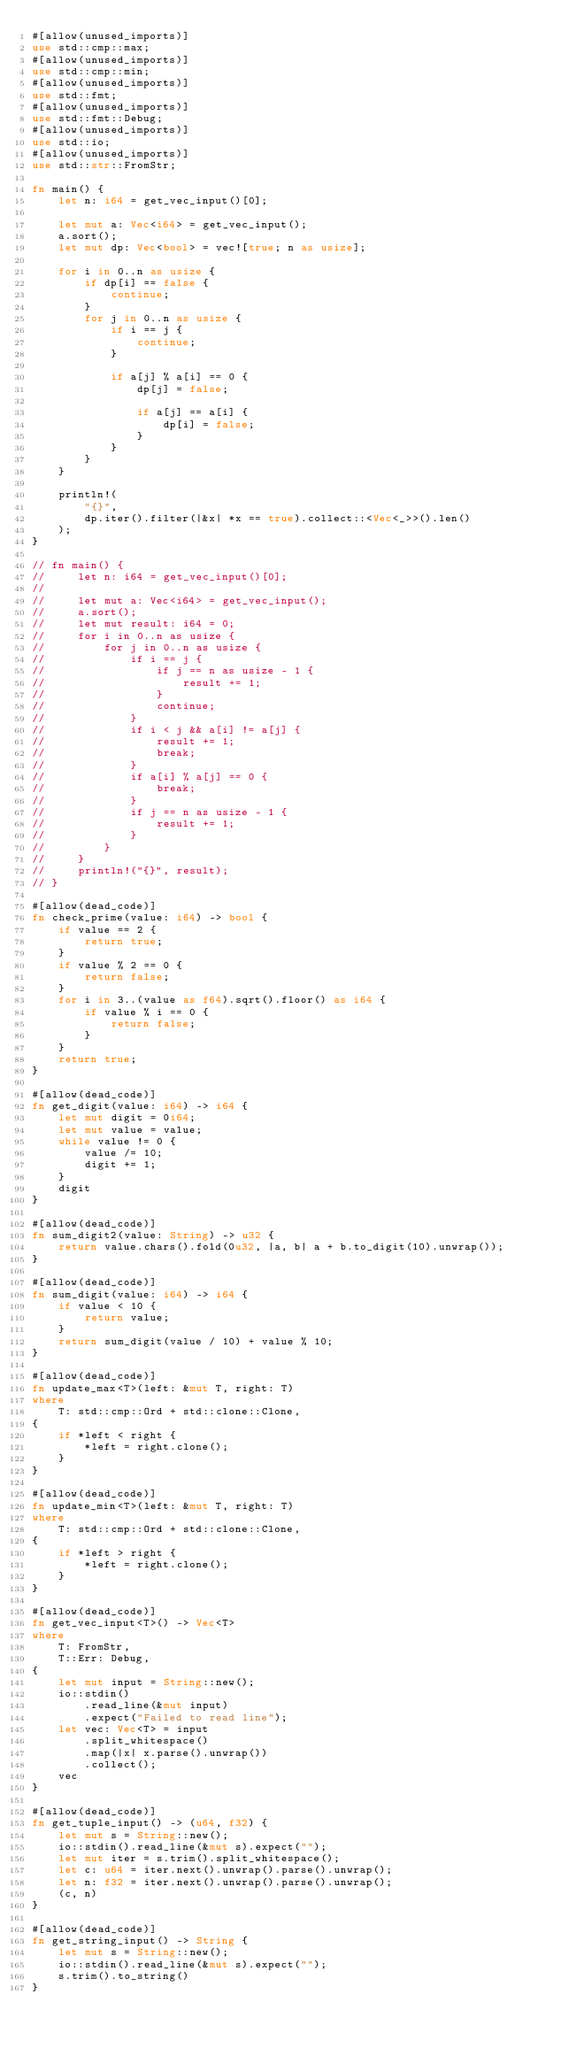Convert code to text. <code><loc_0><loc_0><loc_500><loc_500><_Rust_>#[allow(unused_imports)]
use std::cmp::max;
#[allow(unused_imports)]
use std::cmp::min;
#[allow(unused_imports)]
use std::fmt;
#[allow(unused_imports)]
use std::fmt::Debug;
#[allow(unused_imports)]
use std::io;
#[allow(unused_imports)]
use std::str::FromStr;

fn main() {
    let n: i64 = get_vec_input()[0];

    let mut a: Vec<i64> = get_vec_input();
    a.sort();
    let mut dp: Vec<bool> = vec![true; n as usize];

    for i in 0..n as usize {
        if dp[i] == false {
            continue;
        }
        for j in 0..n as usize {
            if i == j {
                continue;
            }

            if a[j] % a[i] == 0 {
                dp[j] = false;

                if a[j] == a[i] {
                    dp[i] = false;
                }
            }
        }
    }

    println!(
        "{}",
        dp.iter().filter(|&x| *x == true).collect::<Vec<_>>().len()
    );
}

// fn main() {
//     let n: i64 = get_vec_input()[0];
//
//     let mut a: Vec<i64> = get_vec_input();
//     a.sort();
//     let mut result: i64 = 0;
//     for i in 0..n as usize {
//         for j in 0..n as usize {
//             if i == j {
//                 if j == n as usize - 1 {
//                     result += 1;
//                 }
//                 continue;
//             }
//             if i < j && a[i] != a[j] {
//                 result += 1;
//                 break;
//             }
//             if a[i] % a[j] == 0 {
//                 break;
//             }
//             if j == n as usize - 1 {
//                 result += 1;
//             }
//         }
//     }
//     println!("{}", result);
// }

#[allow(dead_code)]
fn check_prime(value: i64) -> bool {
    if value == 2 {
        return true;
    }
    if value % 2 == 0 {
        return false;
    }
    for i in 3..(value as f64).sqrt().floor() as i64 {
        if value % i == 0 {
            return false;
        }
    }
    return true;
}

#[allow(dead_code)]
fn get_digit(value: i64) -> i64 {
    let mut digit = 0i64;
    let mut value = value;
    while value != 0 {
        value /= 10;
        digit += 1;
    }
    digit
}

#[allow(dead_code)]
fn sum_digit2(value: String) -> u32 {
    return value.chars().fold(0u32, |a, b| a + b.to_digit(10).unwrap());
}

#[allow(dead_code)]
fn sum_digit(value: i64) -> i64 {
    if value < 10 {
        return value;
    }
    return sum_digit(value / 10) + value % 10;
}

#[allow(dead_code)]
fn update_max<T>(left: &mut T, right: T)
where
    T: std::cmp::Ord + std::clone::Clone,
{
    if *left < right {
        *left = right.clone();
    }
}

#[allow(dead_code)]
fn update_min<T>(left: &mut T, right: T)
where
    T: std::cmp::Ord + std::clone::Clone,
{
    if *left > right {
        *left = right.clone();
    }
}

#[allow(dead_code)]
fn get_vec_input<T>() -> Vec<T>
where
    T: FromStr,
    T::Err: Debug,
{
    let mut input = String::new();
    io::stdin()
        .read_line(&mut input)
        .expect("Failed to read line");
    let vec: Vec<T> = input
        .split_whitespace()
        .map(|x| x.parse().unwrap())
        .collect();
    vec
}

#[allow(dead_code)]
fn get_tuple_input() -> (u64, f32) {
    let mut s = String::new();
    io::stdin().read_line(&mut s).expect("");
    let mut iter = s.trim().split_whitespace();
    let c: u64 = iter.next().unwrap().parse().unwrap();
    let n: f32 = iter.next().unwrap().parse().unwrap();
    (c, n)
}

#[allow(dead_code)]
fn get_string_input() -> String {
    let mut s = String::new();
    io::stdin().read_line(&mut s).expect("");
    s.trim().to_string()
}
</code> 